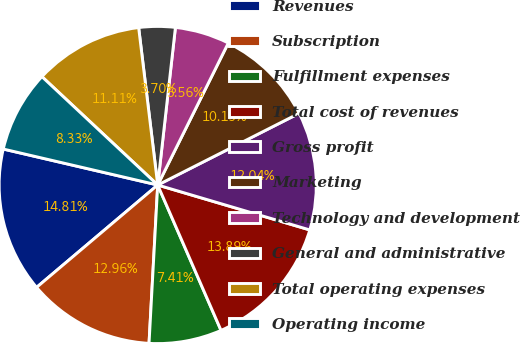<chart> <loc_0><loc_0><loc_500><loc_500><pie_chart><fcel>Revenues<fcel>Subscription<fcel>Fulfillment expenses<fcel>Total cost of revenues<fcel>Gross profit<fcel>Marketing<fcel>Technology and development<fcel>General and administrative<fcel>Total operating expenses<fcel>Operating income<nl><fcel>14.81%<fcel>12.96%<fcel>7.41%<fcel>13.89%<fcel>12.04%<fcel>10.19%<fcel>5.56%<fcel>3.7%<fcel>11.11%<fcel>8.33%<nl></chart> 